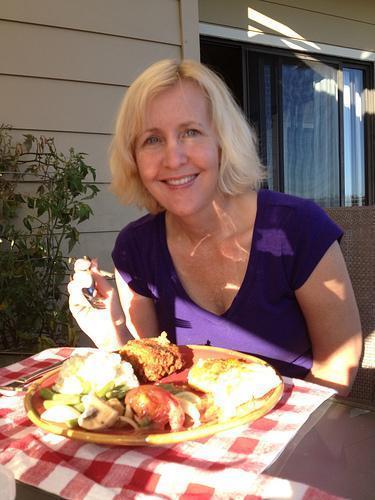How many people are shown?
Give a very brief answer. 1. How many glasses of red wine are there on the right side of the plate?
Give a very brief answer. 0. 